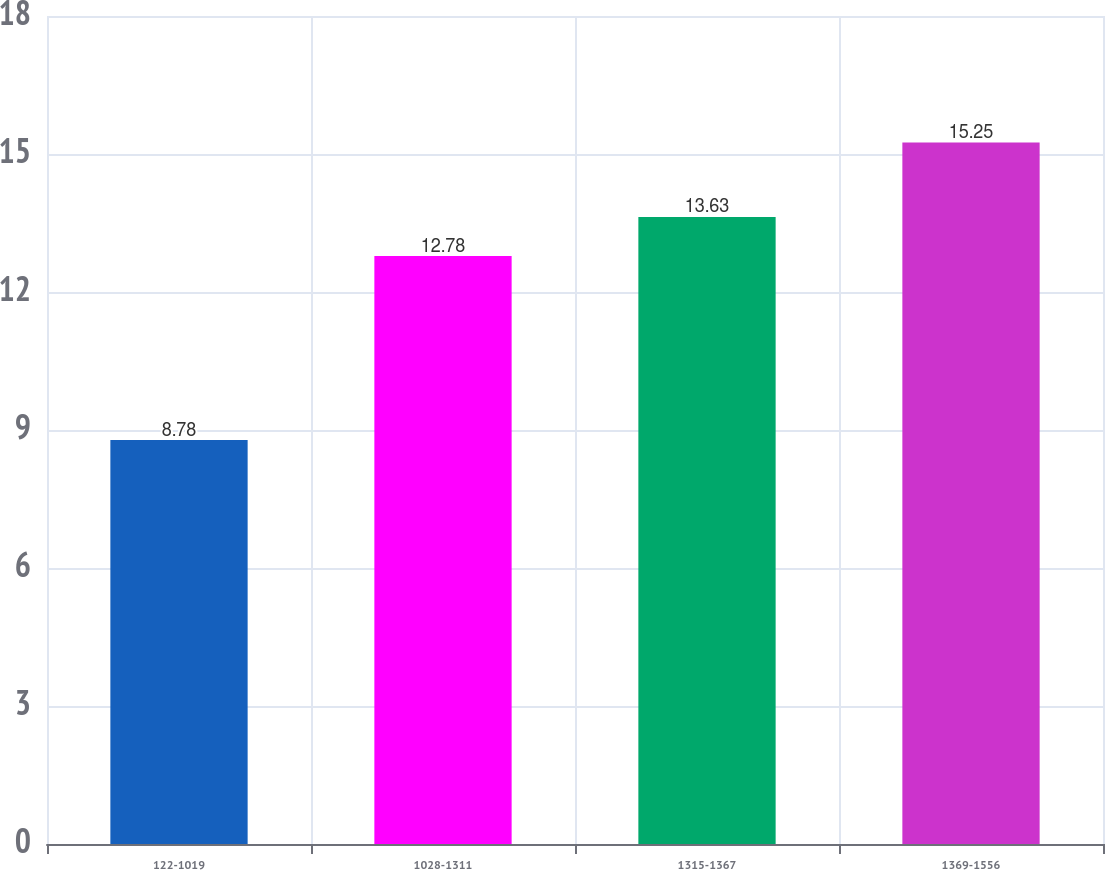Convert chart. <chart><loc_0><loc_0><loc_500><loc_500><bar_chart><fcel>122-1019<fcel>1028-1311<fcel>1315-1367<fcel>1369-1556<nl><fcel>8.78<fcel>12.78<fcel>13.63<fcel>15.25<nl></chart> 